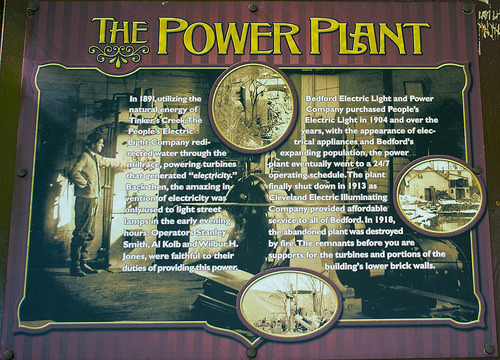<image>
Can you confirm if the tree is in the text? No. The tree is not contained within the text. These objects have a different spatial relationship. Is the text to the left of the man? No. The text is not to the left of the man. From this viewpoint, they have a different horizontal relationship. 